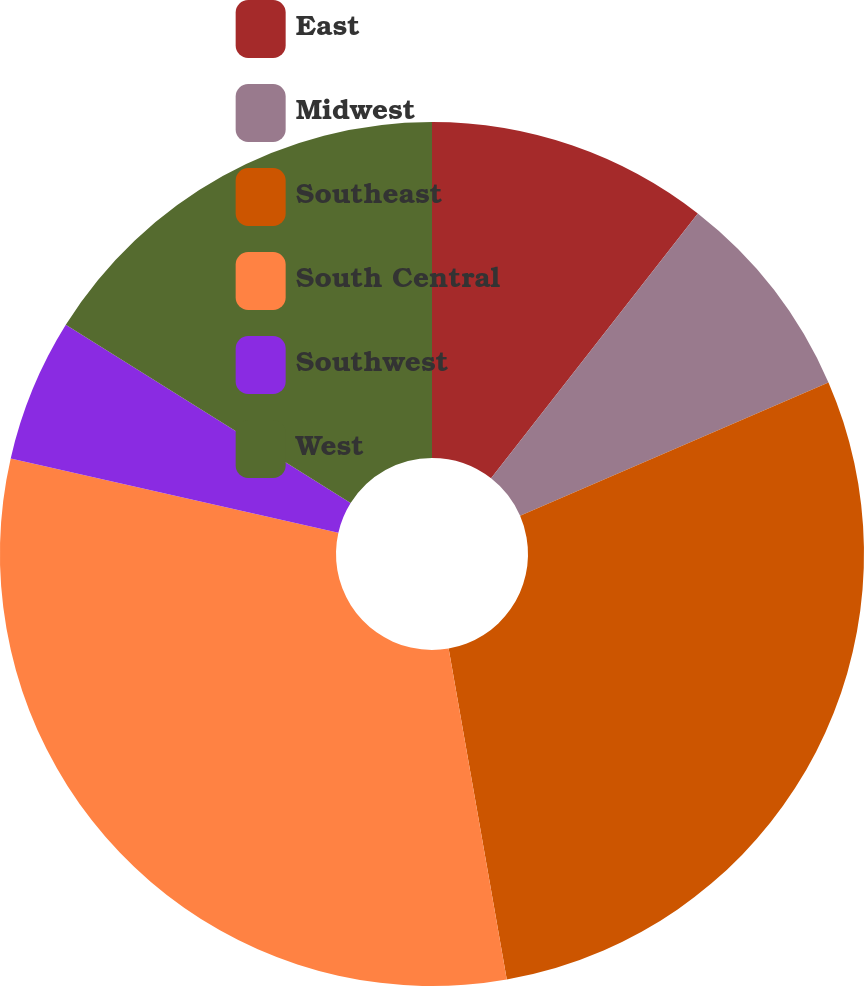Convert chart to OTSL. <chart><loc_0><loc_0><loc_500><loc_500><pie_chart><fcel>East<fcel>Midwest<fcel>Southeast<fcel>South Central<fcel>Southwest<fcel>West<nl><fcel>10.55%<fcel>7.95%<fcel>28.73%<fcel>31.32%<fcel>5.35%<fcel>16.1%<nl></chart> 